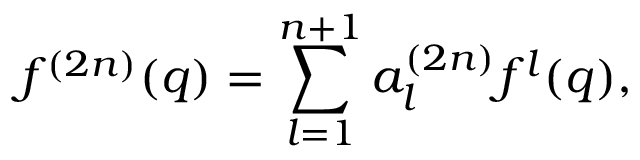Convert formula to latex. <formula><loc_0><loc_0><loc_500><loc_500>f ^ { ( 2 n ) } ( q ) = \sum _ { l = 1 } ^ { n + 1 } a _ { l } ^ { ( 2 n ) } f ^ { l } ( q ) ,</formula> 